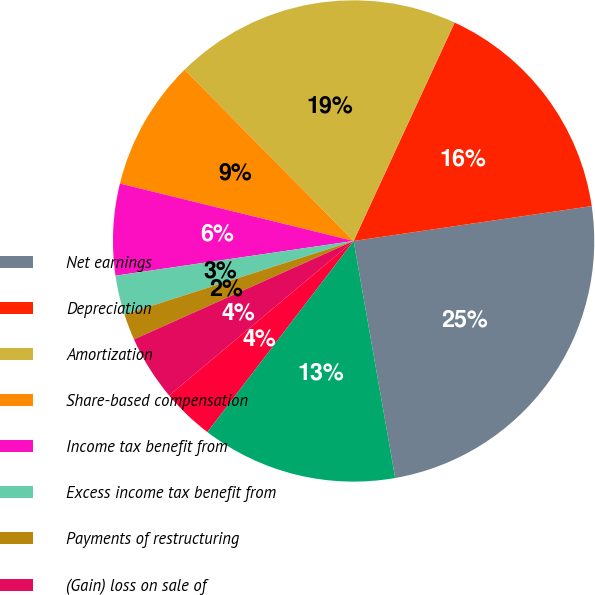Convert chart. <chart><loc_0><loc_0><loc_500><loc_500><pie_chart><fcel>Net earnings<fcel>Depreciation<fcel>Amortization<fcel>Share-based compensation<fcel>Income tax benefit from<fcel>Excess income tax benefit from<fcel>Payments of restructuring<fcel>(Gain) loss on sale of<fcel>Provision for losses on<fcel>Deferred income tax credit<nl><fcel>24.55%<fcel>15.79%<fcel>19.29%<fcel>8.77%<fcel>6.14%<fcel>2.64%<fcel>1.76%<fcel>4.39%<fcel>3.51%<fcel>13.16%<nl></chart> 